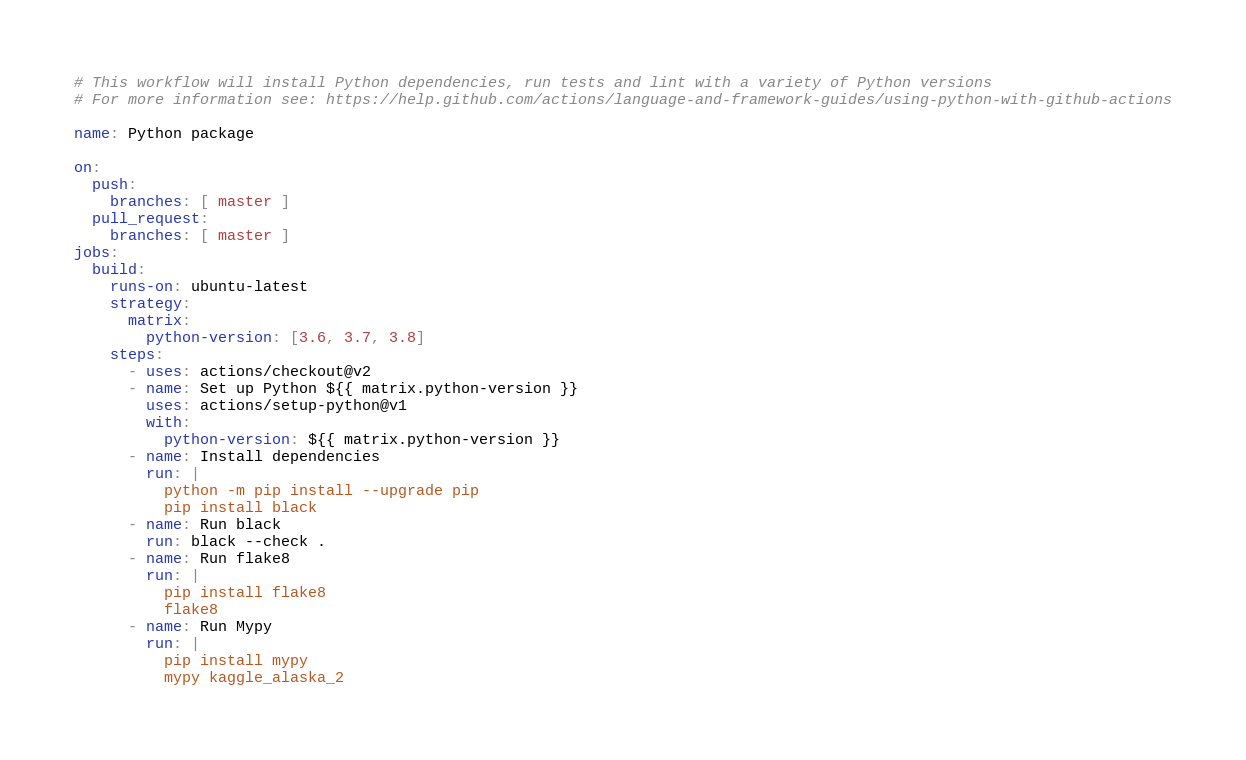Convert code to text. <code><loc_0><loc_0><loc_500><loc_500><_YAML_># This workflow will install Python dependencies, run tests and lint with a variety of Python versions
# For more information see: https://help.github.com/actions/language-and-framework-guides/using-python-with-github-actions

name: Python package

on:
  push:
    branches: [ master ]
  pull_request:
    branches: [ master ]
jobs:
  build:
    runs-on: ubuntu-latest
    strategy:
      matrix:
        python-version: [3.6, 3.7, 3.8]
    steps:
      - uses: actions/checkout@v2
      - name: Set up Python ${{ matrix.python-version }}
        uses: actions/setup-python@v1
        with:
          python-version: ${{ matrix.python-version }}
      - name: Install dependencies
        run: |
          python -m pip install --upgrade pip
          pip install black
      - name: Run black
        run: black --check .
      - name: Run flake8
        run: |
          pip install flake8
          flake8
      - name: Run Mypy
        run: |
          pip install mypy
          mypy kaggle_alaska_2
</code> 